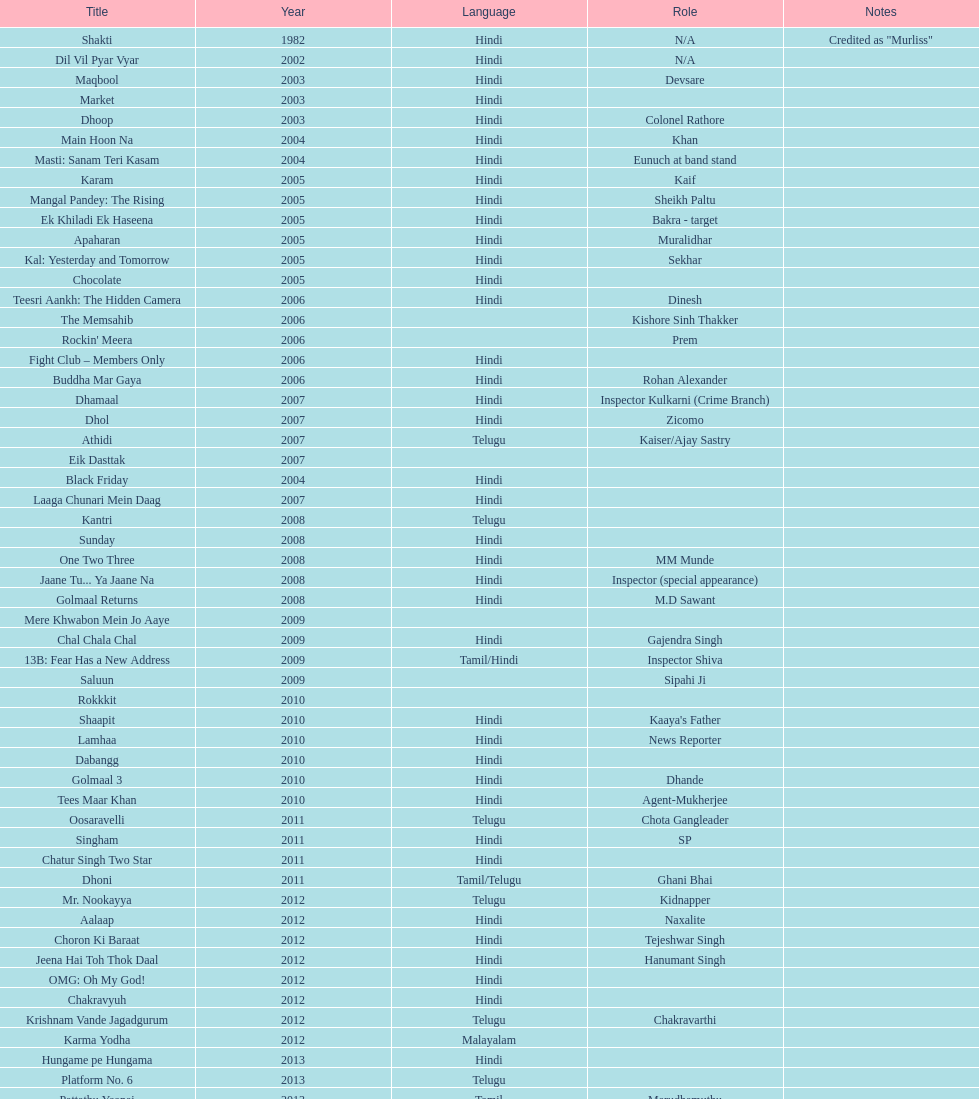What is the title prior to dhol in 2007? Dhamaal. 